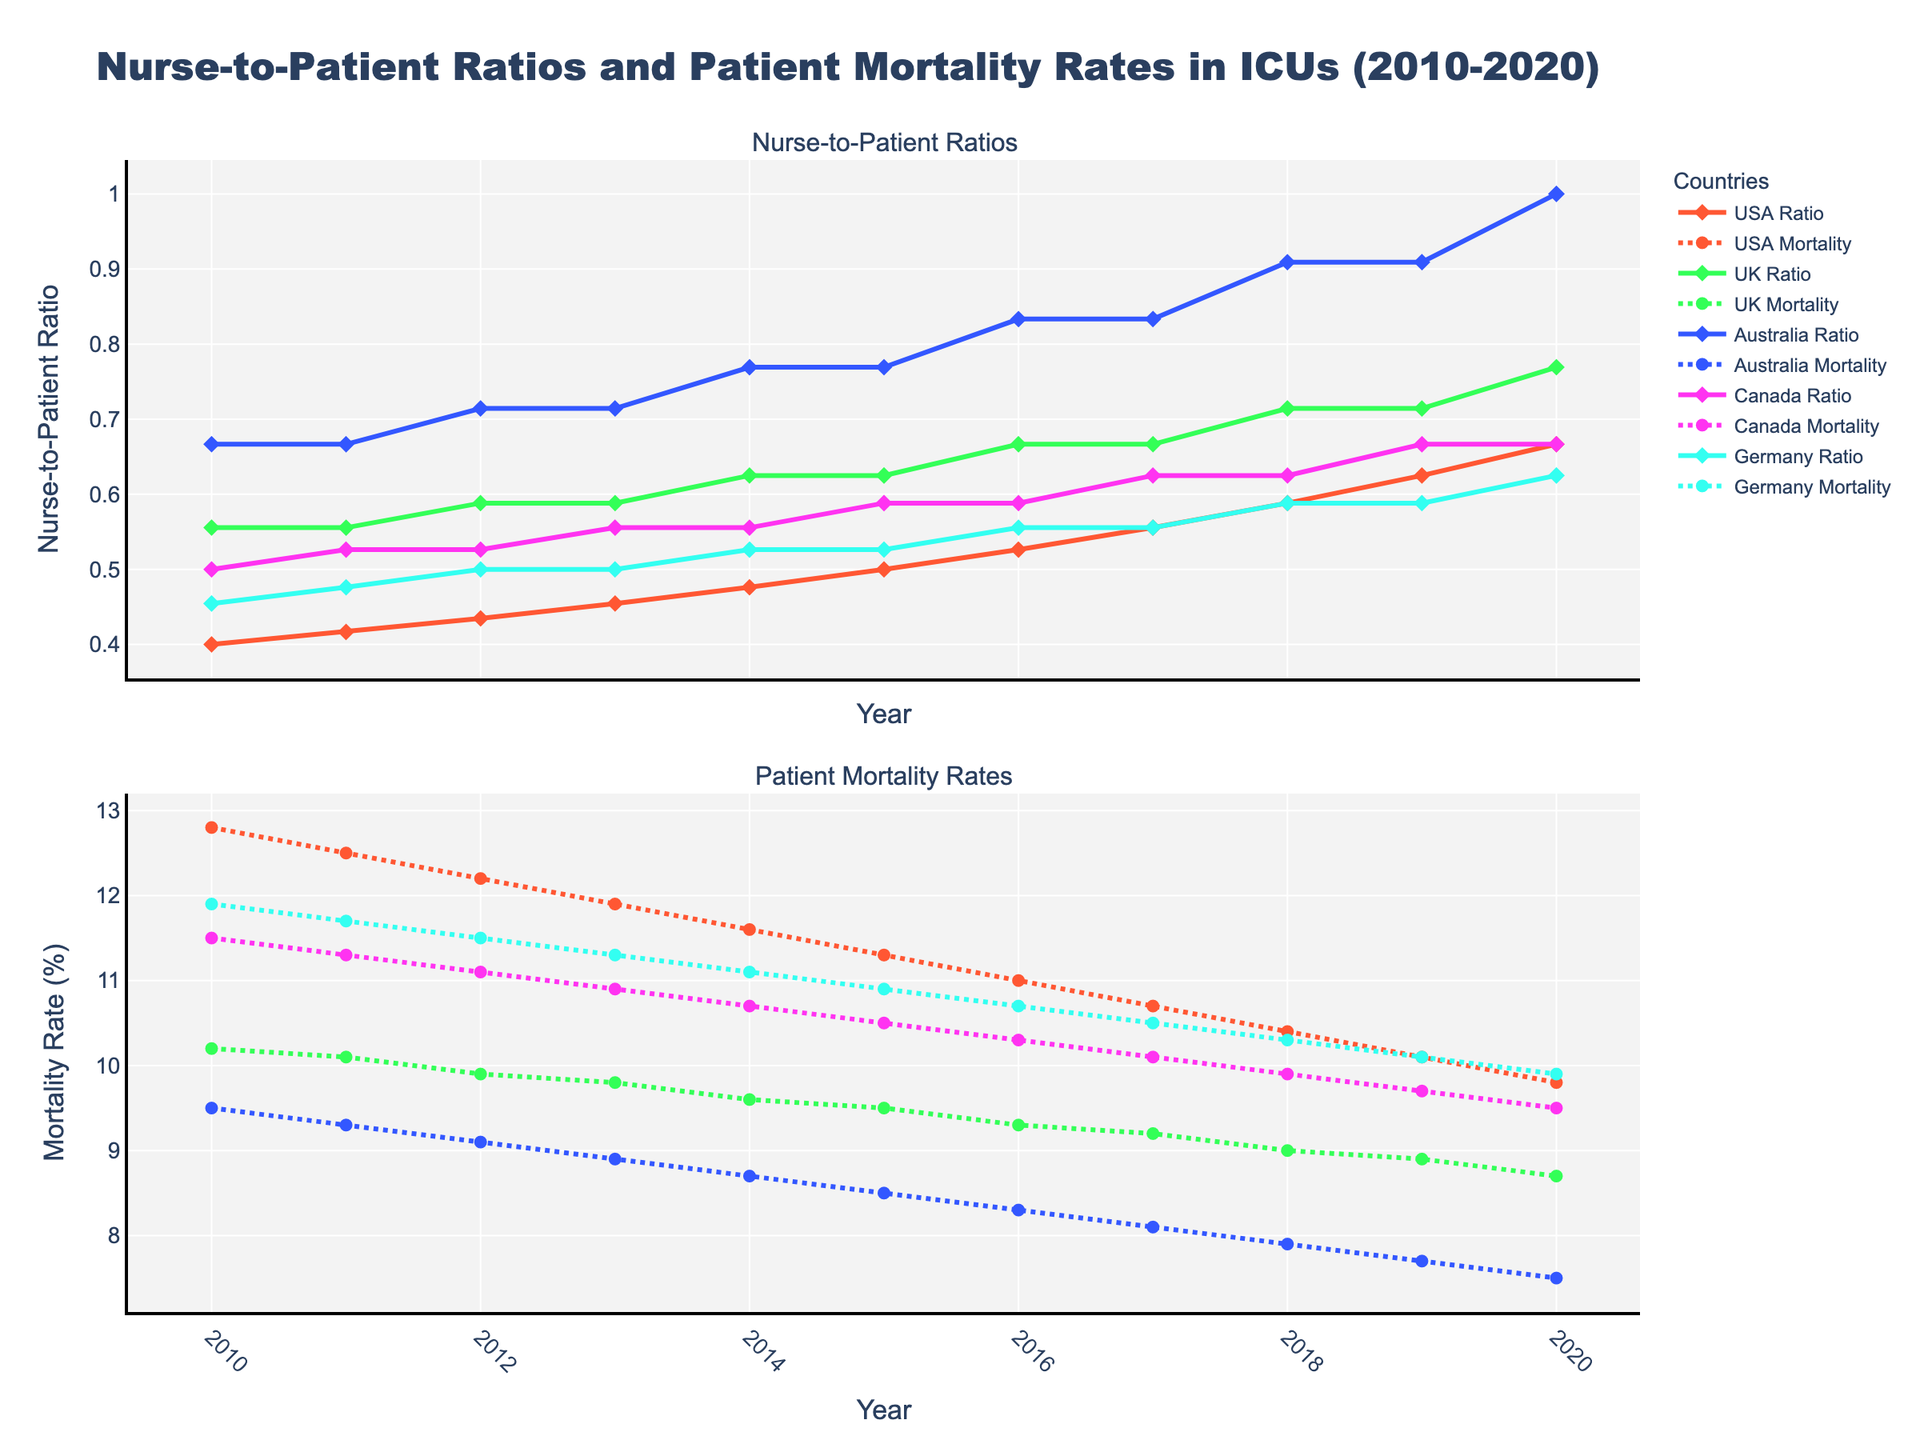What is the general trend of nurse-to-patient ratios in the USA from 2010 to 2020? Observing the first subplot, the nurse-to-patient ratio in the USA continually decreases over the years, starting from approximately 1:2.5 in 2010 to around 1:1.5 in 2020.
Answer: Decreasing Which country had the lowest patient mortality rate in 2020? In the second subplot for the year 2020, Australia has the lowest patient mortality rate around 7.5%.
Answer: Australia By how much did Canada's nurse-to-patient ratio change from 2010 to 2020? In the first subplot, Canada's ratio changes from approximately 1:2.0 in 2010 to about 1:1.5 in 2020. The difference is 0.5.
Answer: 0.5 Which country shows the most significant improvement in patient mortality rates over the period? By comparing the mortality rates in the second subplot, Australia improved the most, reducing mortality from about 9.5% in 2010 to around 7.5% in 2020. The difference is 2%.
Answer: Australia Compare the nurse-to-patient ratio improvement rates in the UK and Germany between 2010 and 2020. In the first subplot, UK's ratio improves from ~1:1.8 in 2010 to ~1:1.3 in 2020, a difference of 0.5. Germany's ratio improves from ~1:2.2 in 2010 to ~1:1.6 in 2020, a difference of 0.6. So, Germany improved slightly more.
Answer: Germany What is the percentage reduction in Canada's patient mortality rate from 2010 to 2020? Canada's mortality rate drops from 11.5% in 2010 to 9.5% in 2020. The percentage reduction is ((11.5 - 9.5)/11.5) * 100 ≈ 17.39%.
Answer: 17.39% Between 2012 and 2017, which year's nurse-to-patient ratio in the UK remained unchanged? In the first subplot, from 2012 to 2017, UK's ratio remains constant at around 1:1.5.
Answer: 2012-2017 Which two countries had a nurse-to-patient ratio below 1:2 in 2015? In the first subplot for the year 2015, the UK and Australia had nurse-to-patient ratios below 1:2.
Answer: UK and Australia During which year did Germany have the highest patient mortality rate? In the second subplot, Germany's highest patient mortality rate occurred in 2010 with approximately 11.9%.
Answer: 2010 